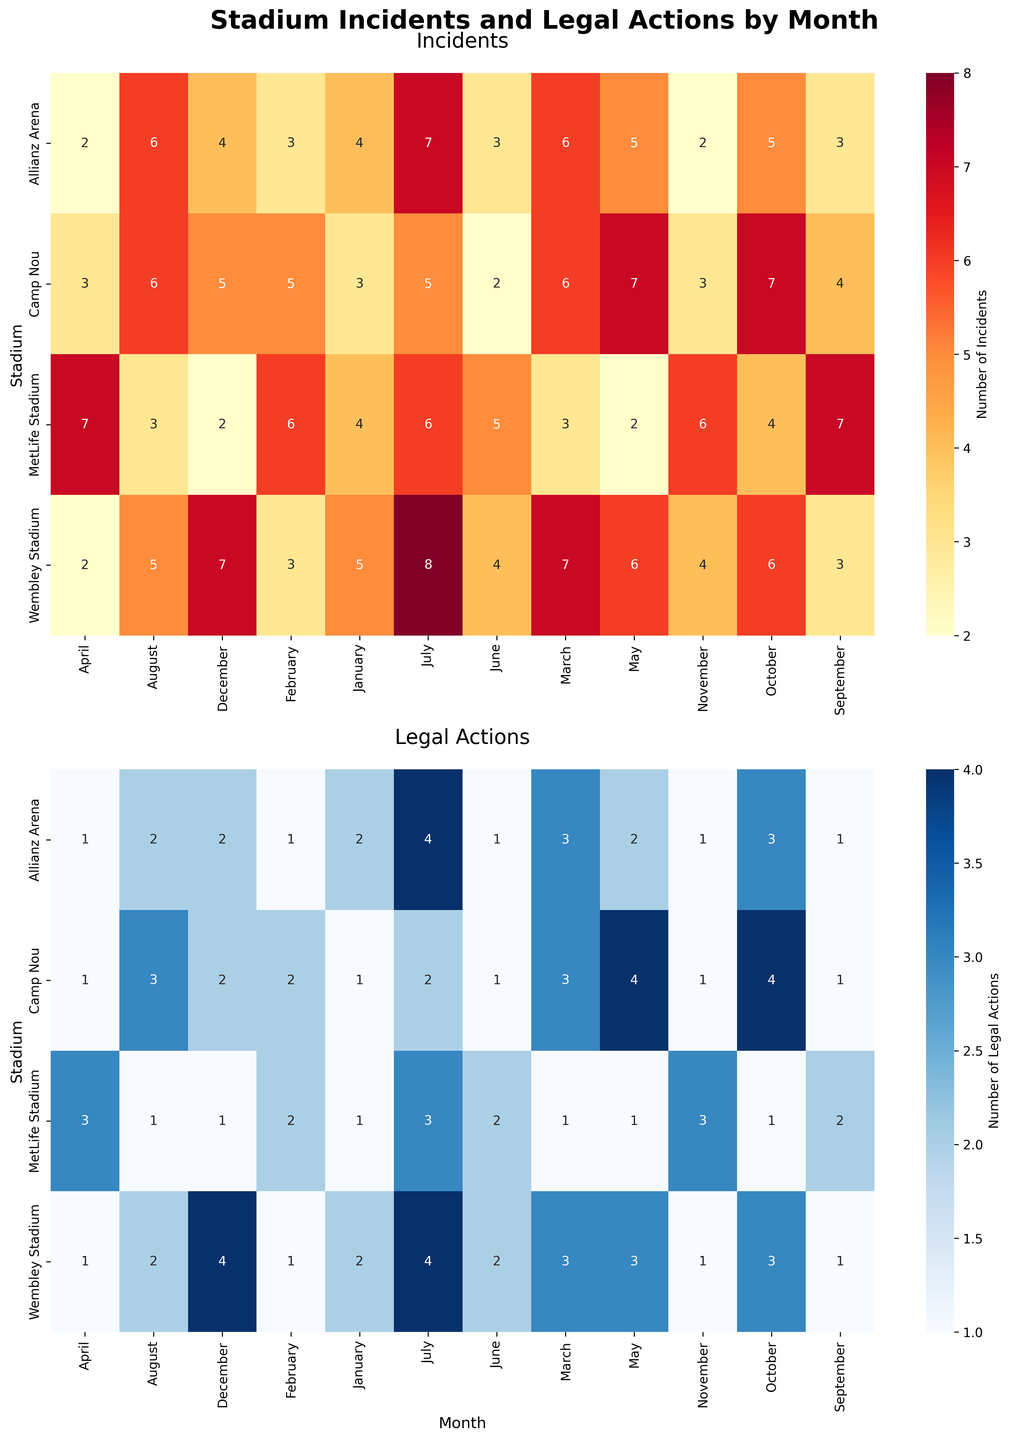How many incidents were reported at Wembley Stadium in July? Look at the "Incidents" heatmap for the intersection of Wembley Stadium and July. The value is 8.
Answer: 8 Which stadium had the highest number of legal actions in May? Refer to the "Legal Actions" heatmap and find the maximum value for May. Camp Nou had the highest number with 4 legal actions.
Answer: Camp Nou What is the average number of incidents reported at Camp Nou across all months? Sum the number of incidents at Camp Nou across all months (3 + 5 + 6 + 3 + 7 + 2 + 5 + 6 + 4 + 7 + 3 + 5 = 56) and divide by 12 (the number of months).
Answer: 4.67 Which month had the fewest incidents at Allianz Arena? Check the "Incidents" heatmap for Allianz Arena, and identify the month with the smallest value. Both April and November have the minimum value of 2.
Answer: April and November Was there a month where MetLife Stadium reported exactly 5 legal actions? Check the "Legal Actions" heatmap for MetLife Stadium. No month has exactly 5 legal actions.
Answer: No How many incidents were reported at all stadiums combined in October? Sum the incidents reported for all stadiums in October: 6 (Wembley) + 4 (MetLife) + 7 (Camp Nou) + 5 (Allianz Arena). The total is 22.
Answer: 22 Compare the legal actions in July between Wembley Stadium and Allianz Arena. Which one had more? Look at the "Legal Actions" heatmap for July. Wembley Stadium has 4 legal actions and Allianz Arena also has 4 legal actions, so they are equal.
Answer: Equal Which stadium had the least amount of legal actions overall? Sum the legal actions for each stadium and compare totals:
- Wembley Stadium: 2 + 1 + 3 + 1 + 3 + 2 + 4 + 2 + 1 + 3 + 1 + 4 = 27
- MetLife Stadium: 1 + 2 + 1 + 3 + 1 + 2 + 3 + 1 + 2 + 1 + 3 + 1 = 21
- Camp Nou: 1 + 2 + 3 + 1 + 4 + 1 + 2 + 3 + 1 + 4 + 1 + 2 = 25
- Allianz Arena: 2 + 1 + 3 + 1 + 2 + 1 + 4 + 2 + 1 + 3 + 1 + 2 = 23
MetLife Stadium has the least with 21 legal actions.
Answer: MetLife Stadium What is the difference in the total number of incidents between MetLife Stadium and Allianz Arena? Sum the total number of incidents for each stadium and calculate the difference:
- MetLife Stadium: 4 + 6 + 3 + 7 + 2 + 5 + 6 + 3 + 7 + 4 + 6 + 2 = 55
- Allianz Arena: 4 + 3 + 6 + 2 + 5 + 3 + 7 + 6 + 3 + 5 + 2 + 4 = 50
The difference is 55 - 50 = 5.
Answer: 5 